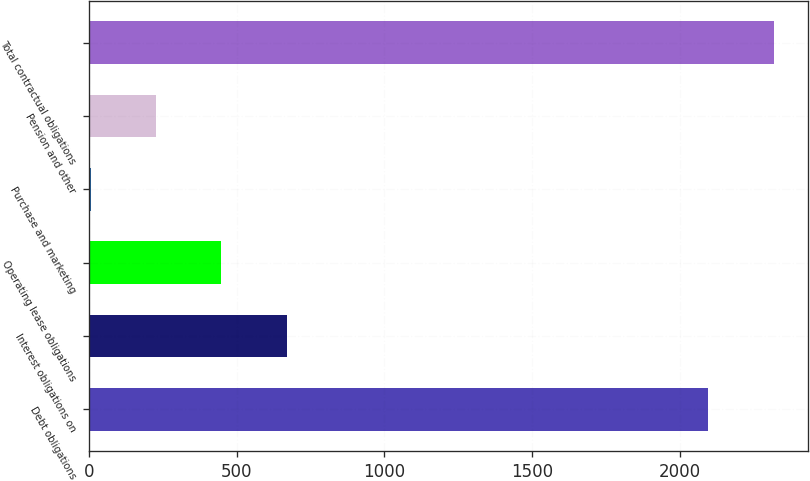Convert chart to OTSL. <chart><loc_0><loc_0><loc_500><loc_500><bar_chart><fcel>Debt obligations<fcel>Interest obligations on<fcel>Operating lease obligations<fcel>Purchase and marketing<fcel>Pension and other<fcel>Total contractual obligations<nl><fcel>2096.2<fcel>669.02<fcel>447.68<fcel>5<fcel>226.34<fcel>2317.54<nl></chart> 